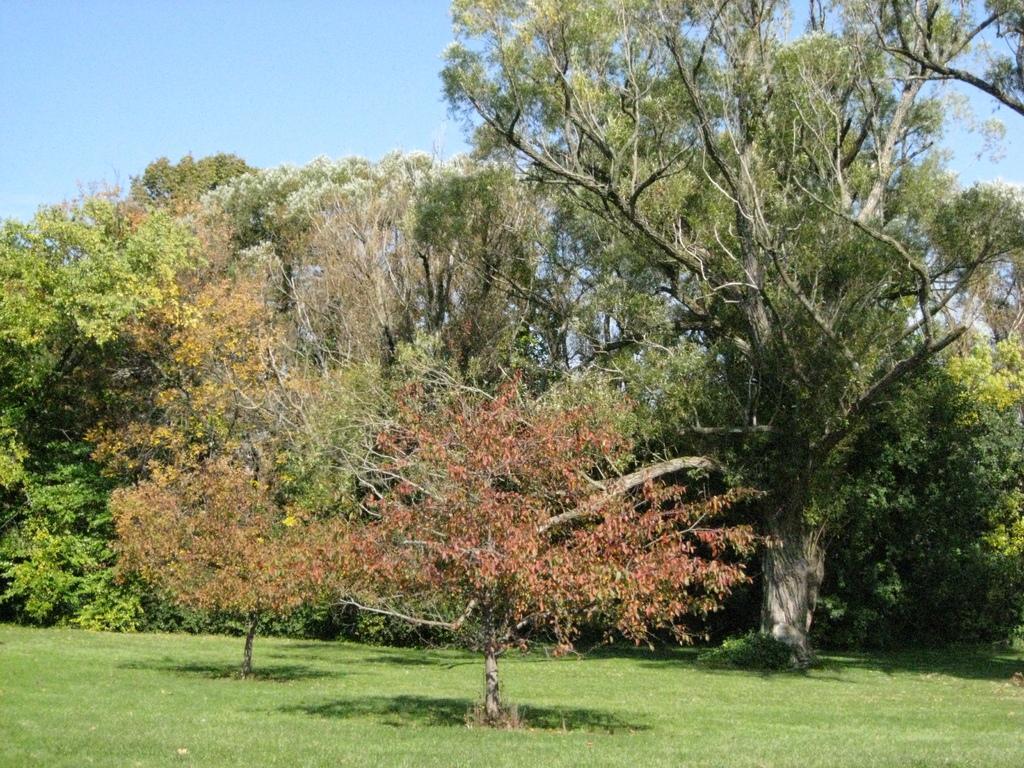Please provide a concise description of this image. In this image I can see many trees which are in red, yellow, green and white color. In the background I can see the blue sky. 